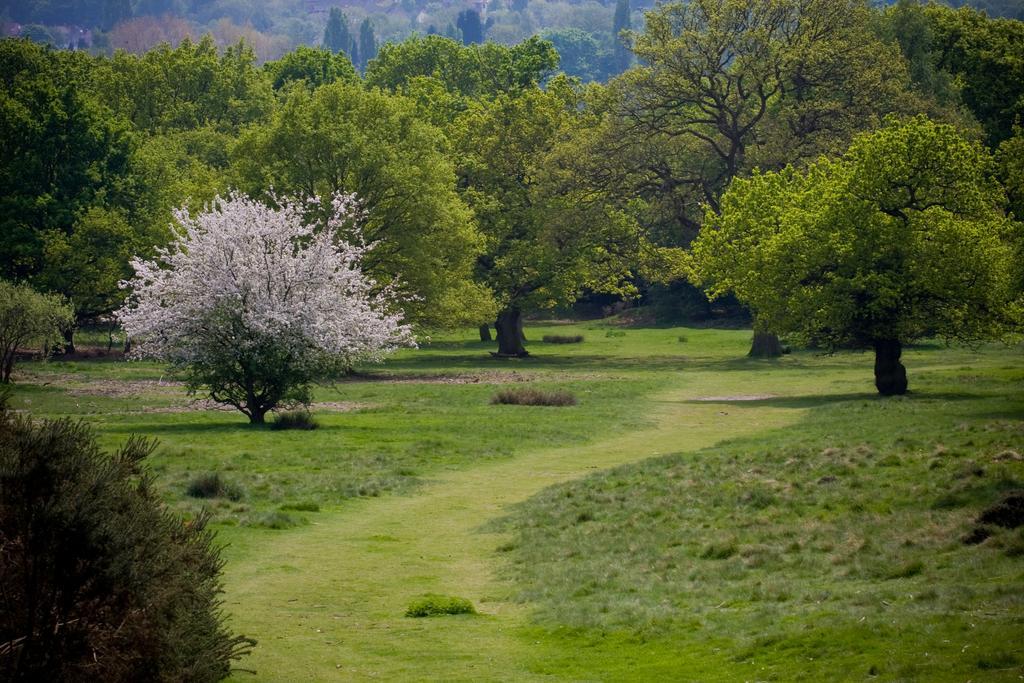Could you give a brief overview of what you see in this image? In this picture I can see grass, and in the background there are trees. 